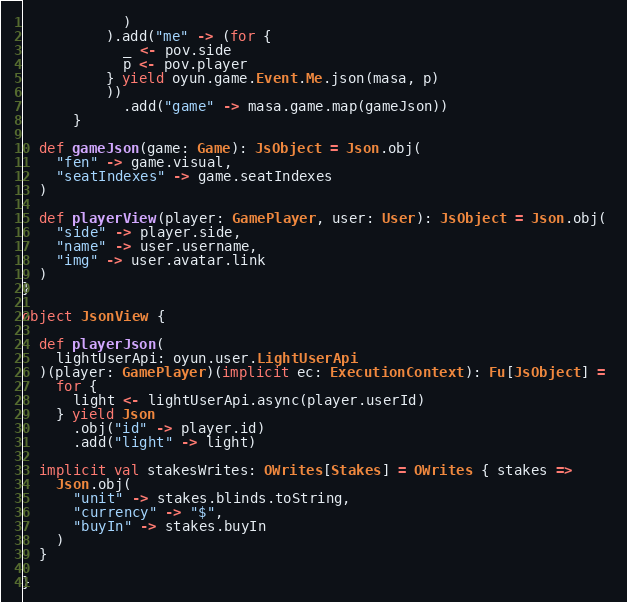<code> <loc_0><loc_0><loc_500><loc_500><_Scala_>            )
          ).add("me" -> (for {
            _ <- pov.side
            p <- pov.player
          } yield oyun.game.Event.Me.json(masa, p)
          ))
            .add("game" -> masa.game.map(gameJson))
      }

  def gameJson(game: Game): JsObject = Json.obj(
    "fen" -> game.visual,
    "seatIndexes" -> game.seatIndexes
  )

  def playerView(player: GamePlayer, user: User): JsObject = Json.obj(
    "side" -> player.side,
    "name" -> user.username,
    "img" -> user.avatar.link
  )
}

object JsonView {

  def playerJson(
    lightUserApi: oyun.user.LightUserApi
  )(player: GamePlayer)(implicit ec: ExecutionContext): Fu[JsObject] = 
    for {
      light <- lightUserApi.async(player.userId)
    } yield Json
      .obj("id" -> player.id)
      .add("light" -> light)

  implicit val stakesWrites: OWrites[Stakes] = OWrites { stakes =>
    Json.obj(
      "unit" -> stakes.blinds.toString,
      "currency" -> "$",
      "buyIn" -> stakes.buyIn
    )
  }
  
}
</code> 